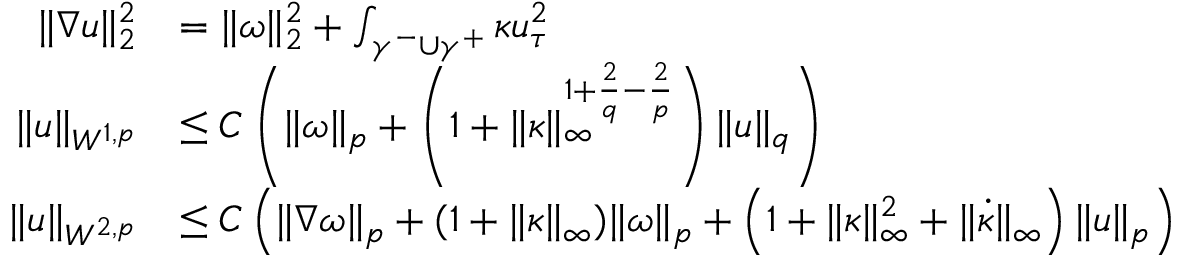<formula> <loc_0><loc_0><loc_500><loc_500>\begin{array} { r l } { \| \nabla u \| _ { 2 } ^ { 2 } } & { = \| \omega \| _ { 2 } ^ { 2 } + \int _ { \gamma ^ { - } \cup \gamma ^ { + } } \kappa u _ { \tau } ^ { 2 } } \\ { \| u \| _ { W ^ { 1 , p } } } & { \leq C \left ( \| \omega \| _ { p } + \left ( 1 + \| \kappa \| _ { \infty } ^ { 1 + \frac { 2 } { q } - \frac { 2 } { p } } \right ) \| u \| _ { q } \right ) } \\ { \| u \| _ { W ^ { 2 , p } } } & { \leq C \left ( \| \nabla \omega \| _ { p } + ( 1 + \| \kappa \| _ { \infty } ) \| \omega \| _ { p } + \left ( 1 + \| \kappa \| _ { \infty } ^ { 2 } + \| \dot { \kappa } \| _ { \infty } \right ) \| u \| _ { p } \right ) } \end{array}</formula> 